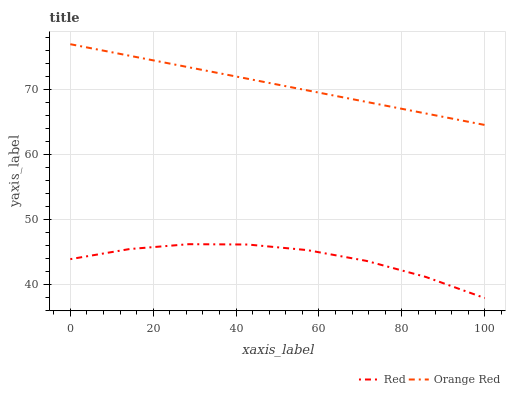Does Red have the minimum area under the curve?
Answer yes or no. Yes. Does Orange Red have the maximum area under the curve?
Answer yes or no. Yes. Does Red have the maximum area under the curve?
Answer yes or no. No. Is Orange Red the smoothest?
Answer yes or no. Yes. Is Red the roughest?
Answer yes or no. Yes. Is Red the smoothest?
Answer yes or no. No. Does Orange Red have the highest value?
Answer yes or no. Yes. Does Red have the highest value?
Answer yes or no. No. Is Red less than Orange Red?
Answer yes or no. Yes. Is Orange Red greater than Red?
Answer yes or no. Yes. Does Red intersect Orange Red?
Answer yes or no. No. 